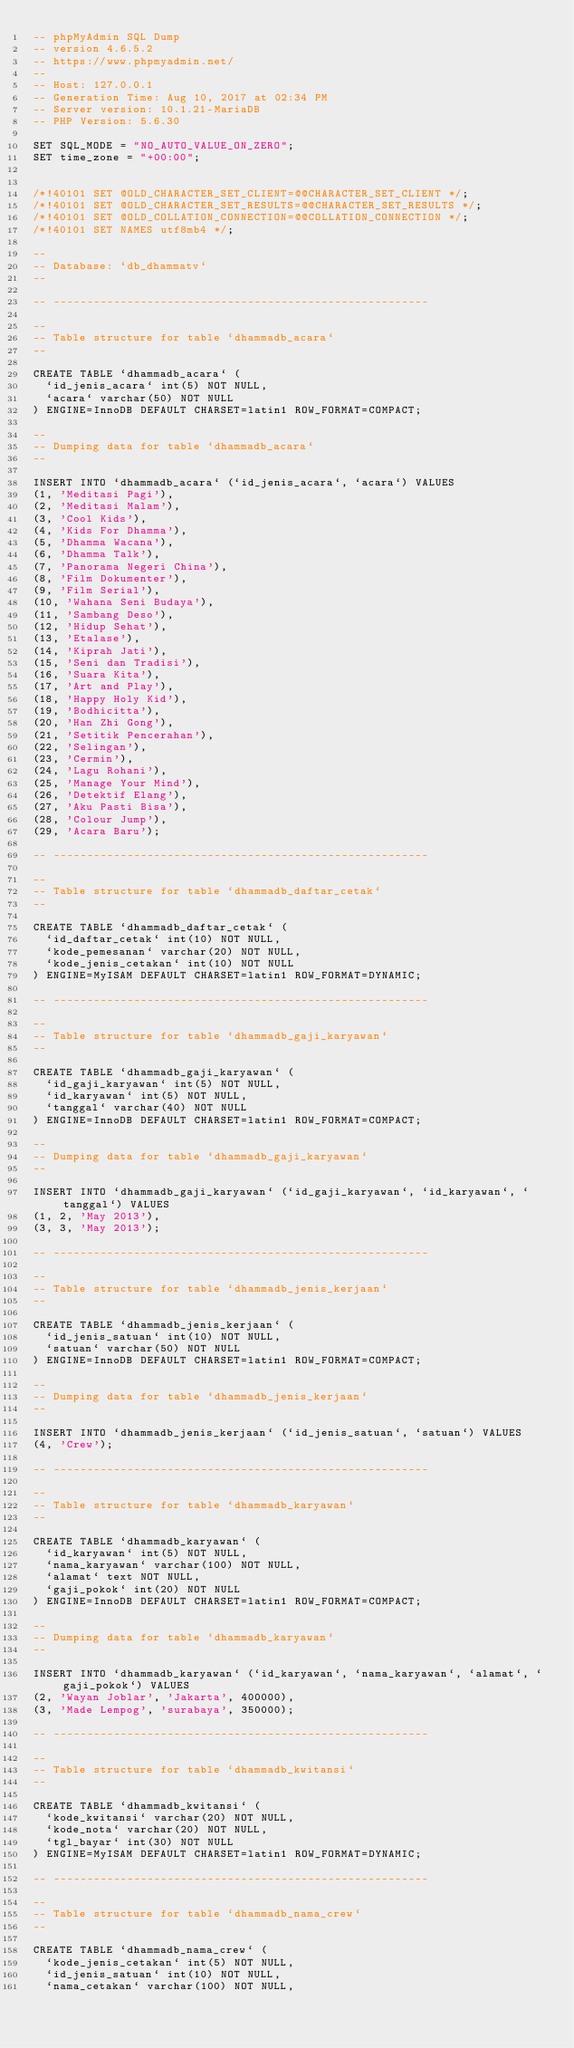Convert code to text. <code><loc_0><loc_0><loc_500><loc_500><_SQL_>-- phpMyAdmin SQL Dump
-- version 4.6.5.2
-- https://www.phpmyadmin.net/
--
-- Host: 127.0.0.1
-- Generation Time: Aug 10, 2017 at 02:34 PM
-- Server version: 10.1.21-MariaDB
-- PHP Version: 5.6.30

SET SQL_MODE = "NO_AUTO_VALUE_ON_ZERO";
SET time_zone = "+00:00";


/*!40101 SET @OLD_CHARACTER_SET_CLIENT=@@CHARACTER_SET_CLIENT */;
/*!40101 SET @OLD_CHARACTER_SET_RESULTS=@@CHARACTER_SET_RESULTS */;
/*!40101 SET @OLD_COLLATION_CONNECTION=@@COLLATION_CONNECTION */;
/*!40101 SET NAMES utf8mb4 */;

--
-- Database: `db_dhammatv`
--

-- --------------------------------------------------------

--
-- Table structure for table `dhammadb_acara`
--

CREATE TABLE `dhammadb_acara` (
  `id_jenis_acara` int(5) NOT NULL,
  `acara` varchar(50) NOT NULL
) ENGINE=InnoDB DEFAULT CHARSET=latin1 ROW_FORMAT=COMPACT;

--
-- Dumping data for table `dhammadb_acara`
--

INSERT INTO `dhammadb_acara` (`id_jenis_acara`, `acara`) VALUES
(1, 'Meditasi Pagi'),
(2, 'Meditasi Malam'),
(3, 'Cool Kids'),
(4, 'Kids For Dhamma'),
(5, 'Dhamma Wacana'),
(6, 'Dhamma Talk'),
(7, 'Panorama Negeri China'),
(8, 'Film Dokumenter'),
(9, 'Film Serial'),
(10, 'Wahana Seni Budaya'),
(11, 'Sambang Deso'),
(12, 'Hidup Sehat'),
(13, 'Etalase'),
(14, 'Kiprah Jati'),
(15, 'Seni dan Tradisi'),
(16, 'Suara Kita'),
(17, 'Art and Play'),
(18, 'Happy Holy Kid'),
(19, 'Bodhicitta'),
(20, 'Han Zhi Gong'),
(21, 'Setitik Pencerahan'),
(22, 'Selingan'),
(23, 'Cermin'),
(24, 'Lagu Rohani'),
(25, 'Manage Your Mind'),
(26, 'Detektif Elang'),
(27, 'Aku Pasti Bisa'),
(28, 'Colour Jump'),
(29, 'Acara Baru');

-- --------------------------------------------------------

--
-- Table structure for table `dhammadb_daftar_cetak`
--

CREATE TABLE `dhammadb_daftar_cetak` (
  `id_daftar_cetak` int(10) NOT NULL,
  `kode_pemesanan` varchar(20) NOT NULL,
  `kode_jenis_cetakan` int(10) NOT NULL
) ENGINE=MyISAM DEFAULT CHARSET=latin1 ROW_FORMAT=DYNAMIC;

-- --------------------------------------------------------

--
-- Table structure for table `dhammadb_gaji_karyawan`
--

CREATE TABLE `dhammadb_gaji_karyawan` (
  `id_gaji_karyawan` int(5) NOT NULL,
  `id_karyawan` int(5) NOT NULL,
  `tanggal` varchar(40) NOT NULL
) ENGINE=InnoDB DEFAULT CHARSET=latin1 ROW_FORMAT=COMPACT;

--
-- Dumping data for table `dhammadb_gaji_karyawan`
--

INSERT INTO `dhammadb_gaji_karyawan` (`id_gaji_karyawan`, `id_karyawan`, `tanggal`) VALUES
(1, 2, 'May 2013'),
(3, 3, 'May 2013');

-- --------------------------------------------------------

--
-- Table structure for table `dhammadb_jenis_kerjaan`
--

CREATE TABLE `dhammadb_jenis_kerjaan` (
  `id_jenis_satuan` int(10) NOT NULL,
  `satuan` varchar(50) NOT NULL
) ENGINE=InnoDB DEFAULT CHARSET=latin1 ROW_FORMAT=COMPACT;

--
-- Dumping data for table `dhammadb_jenis_kerjaan`
--

INSERT INTO `dhammadb_jenis_kerjaan` (`id_jenis_satuan`, `satuan`) VALUES
(4, 'Crew');

-- --------------------------------------------------------

--
-- Table structure for table `dhammadb_karyawan`
--

CREATE TABLE `dhammadb_karyawan` (
  `id_karyawan` int(5) NOT NULL,
  `nama_karyawan` varchar(100) NOT NULL,
  `alamat` text NOT NULL,
  `gaji_pokok` int(20) NOT NULL
) ENGINE=InnoDB DEFAULT CHARSET=latin1 ROW_FORMAT=COMPACT;

--
-- Dumping data for table `dhammadb_karyawan`
--

INSERT INTO `dhammadb_karyawan` (`id_karyawan`, `nama_karyawan`, `alamat`, `gaji_pokok`) VALUES
(2, 'Wayan Joblar', 'Jakarta', 400000),
(3, 'Made Lempog', 'surabaya', 350000);

-- --------------------------------------------------------

--
-- Table structure for table `dhammadb_kwitansi`
--

CREATE TABLE `dhammadb_kwitansi` (
  `kode_kwitansi` varchar(20) NOT NULL,
  `kode_nota` varchar(20) NOT NULL,
  `tgl_bayar` int(30) NOT NULL
) ENGINE=MyISAM DEFAULT CHARSET=latin1 ROW_FORMAT=DYNAMIC;

-- --------------------------------------------------------

--
-- Table structure for table `dhammadb_nama_crew`
--

CREATE TABLE `dhammadb_nama_crew` (
  `kode_jenis_cetakan` int(5) NOT NULL,
  `id_jenis_satuan` int(10) NOT NULL,
  `nama_cetakan` varchar(100) NOT NULL,</code> 